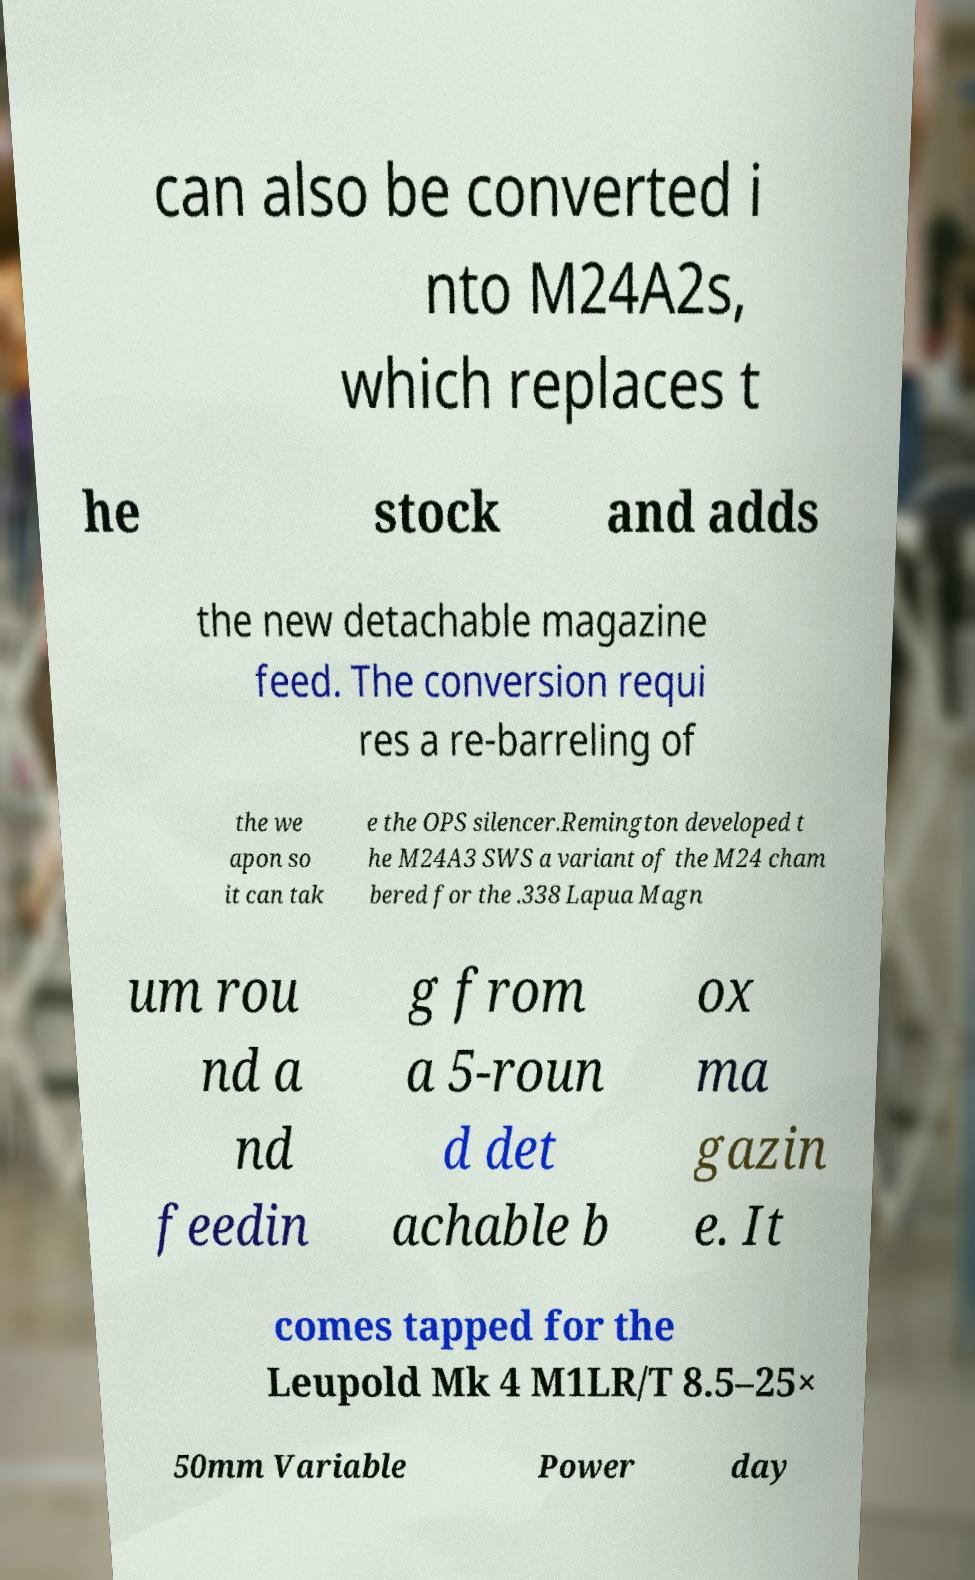Could you assist in decoding the text presented in this image and type it out clearly? can also be converted i nto M24A2s, which replaces t he stock and adds the new detachable magazine feed. The conversion requi res a re-barreling of the we apon so it can tak e the OPS silencer.Remington developed t he M24A3 SWS a variant of the M24 cham bered for the .338 Lapua Magn um rou nd a nd feedin g from a 5-roun d det achable b ox ma gazin e. It comes tapped for the Leupold Mk 4 M1LR/T 8.5–25× 50mm Variable Power day 